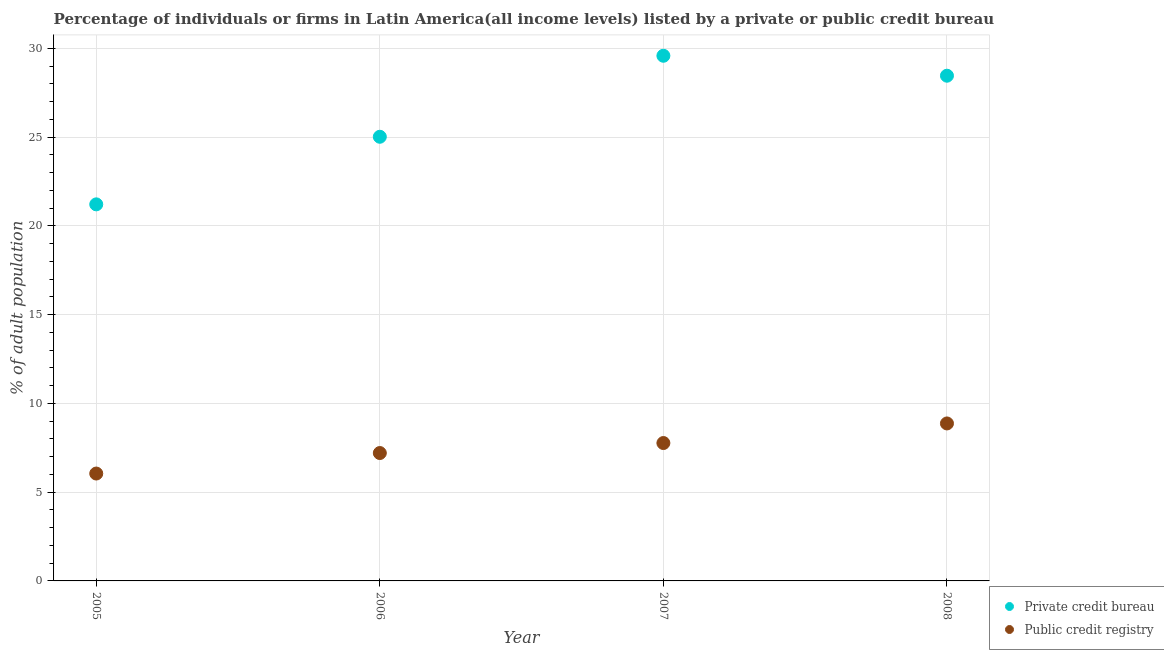Is the number of dotlines equal to the number of legend labels?
Keep it short and to the point. Yes. What is the percentage of firms listed by private credit bureau in 2005?
Provide a succinct answer. 21.21. Across all years, what is the maximum percentage of firms listed by private credit bureau?
Keep it short and to the point. 29.58. Across all years, what is the minimum percentage of firms listed by private credit bureau?
Your answer should be compact. 21.21. In which year was the percentage of firms listed by public credit bureau maximum?
Ensure brevity in your answer.  2008. In which year was the percentage of firms listed by public credit bureau minimum?
Provide a short and direct response. 2005. What is the total percentage of firms listed by private credit bureau in the graph?
Offer a terse response. 104.26. What is the difference between the percentage of firms listed by public credit bureau in 2006 and that in 2008?
Provide a succinct answer. -1.67. What is the difference between the percentage of firms listed by public credit bureau in 2008 and the percentage of firms listed by private credit bureau in 2005?
Provide a short and direct response. -12.34. What is the average percentage of firms listed by private credit bureau per year?
Offer a very short reply. 26.07. In the year 2005, what is the difference between the percentage of firms listed by private credit bureau and percentage of firms listed by public credit bureau?
Your answer should be compact. 15.16. In how many years, is the percentage of firms listed by public credit bureau greater than 8 %?
Provide a succinct answer. 1. What is the ratio of the percentage of firms listed by public credit bureau in 2007 to that in 2008?
Provide a short and direct response. 0.88. What is the difference between the highest and the second highest percentage of firms listed by public credit bureau?
Give a very brief answer. 1.1. What is the difference between the highest and the lowest percentage of firms listed by public credit bureau?
Offer a terse response. 2.82. Is the percentage of firms listed by public credit bureau strictly greater than the percentage of firms listed by private credit bureau over the years?
Offer a terse response. No. How many dotlines are there?
Provide a short and direct response. 2. How many years are there in the graph?
Make the answer very short. 4. What is the difference between two consecutive major ticks on the Y-axis?
Offer a terse response. 5. Does the graph contain grids?
Give a very brief answer. Yes. Where does the legend appear in the graph?
Ensure brevity in your answer.  Bottom right. How are the legend labels stacked?
Provide a succinct answer. Vertical. What is the title of the graph?
Your answer should be very brief. Percentage of individuals or firms in Latin America(all income levels) listed by a private or public credit bureau. Does "IMF nonconcessional" appear as one of the legend labels in the graph?
Provide a short and direct response. No. What is the label or title of the X-axis?
Provide a short and direct response. Year. What is the label or title of the Y-axis?
Offer a very short reply. % of adult population. What is the % of adult population in Private credit bureau in 2005?
Provide a succinct answer. 21.21. What is the % of adult population of Public credit registry in 2005?
Offer a very short reply. 6.05. What is the % of adult population of Private credit bureau in 2006?
Make the answer very short. 25.02. What is the % of adult population of Public credit registry in 2006?
Offer a terse response. 7.2. What is the % of adult population of Private credit bureau in 2007?
Keep it short and to the point. 29.58. What is the % of adult population in Public credit registry in 2007?
Your answer should be very brief. 7.77. What is the % of adult population in Private credit bureau in 2008?
Keep it short and to the point. 28.46. What is the % of adult population of Public credit registry in 2008?
Provide a short and direct response. 8.87. Across all years, what is the maximum % of adult population in Private credit bureau?
Your answer should be very brief. 29.58. Across all years, what is the maximum % of adult population in Public credit registry?
Your answer should be compact. 8.87. Across all years, what is the minimum % of adult population of Private credit bureau?
Your response must be concise. 21.21. Across all years, what is the minimum % of adult population of Public credit registry?
Your response must be concise. 6.05. What is the total % of adult population of Private credit bureau in the graph?
Make the answer very short. 104.26. What is the total % of adult population of Public credit registry in the graph?
Provide a short and direct response. 29.89. What is the difference between the % of adult population of Private credit bureau in 2005 and that in 2006?
Offer a very short reply. -3.81. What is the difference between the % of adult population of Public credit registry in 2005 and that in 2006?
Keep it short and to the point. -1.16. What is the difference between the % of adult population in Private credit bureau in 2005 and that in 2007?
Keep it short and to the point. -8.37. What is the difference between the % of adult population of Public credit registry in 2005 and that in 2007?
Provide a short and direct response. -1.72. What is the difference between the % of adult population in Private credit bureau in 2005 and that in 2008?
Your answer should be very brief. -7.25. What is the difference between the % of adult population of Public credit registry in 2005 and that in 2008?
Your response must be concise. -2.82. What is the difference between the % of adult population of Private credit bureau in 2006 and that in 2007?
Make the answer very short. -4.56. What is the difference between the % of adult population in Public credit registry in 2006 and that in 2007?
Keep it short and to the point. -0.56. What is the difference between the % of adult population in Private credit bureau in 2006 and that in 2008?
Offer a very short reply. -3.44. What is the difference between the % of adult population of Public credit registry in 2006 and that in 2008?
Your response must be concise. -1.67. What is the difference between the % of adult population in Private credit bureau in 2007 and that in 2008?
Provide a short and direct response. 1.12. What is the difference between the % of adult population of Public credit registry in 2007 and that in 2008?
Ensure brevity in your answer.  -1.1. What is the difference between the % of adult population of Private credit bureau in 2005 and the % of adult population of Public credit registry in 2006?
Your response must be concise. 14.01. What is the difference between the % of adult population in Private credit bureau in 2005 and the % of adult population in Public credit registry in 2007?
Give a very brief answer. 13.44. What is the difference between the % of adult population of Private credit bureau in 2005 and the % of adult population of Public credit registry in 2008?
Ensure brevity in your answer.  12.34. What is the difference between the % of adult population in Private credit bureau in 2006 and the % of adult population in Public credit registry in 2007?
Provide a short and direct response. 17.25. What is the difference between the % of adult population of Private credit bureau in 2006 and the % of adult population of Public credit registry in 2008?
Your answer should be very brief. 16.15. What is the difference between the % of adult population of Private credit bureau in 2007 and the % of adult population of Public credit registry in 2008?
Provide a short and direct response. 20.71. What is the average % of adult population in Private credit bureau per year?
Your answer should be compact. 26.07. What is the average % of adult population of Public credit registry per year?
Make the answer very short. 7.47. In the year 2005, what is the difference between the % of adult population of Private credit bureau and % of adult population of Public credit registry?
Give a very brief answer. 15.16. In the year 2006, what is the difference between the % of adult population of Private credit bureau and % of adult population of Public credit registry?
Provide a short and direct response. 17.81. In the year 2007, what is the difference between the % of adult population of Private credit bureau and % of adult population of Public credit registry?
Keep it short and to the point. 21.81. In the year 2008, what is the difference between the % of adult population of Private credit bureau and % of adult population of Public credit registry?
Offer a terse response. 19.59. What is the ratio of the % of adult population in Private credit bureau in 2005 to that in 2006?
Provide a short and direct response. 0.85. What is the ratio of the % of adult population of Public credit registry in 2005 to that in 2006?
Make the answer very short. 0.84. What is the ratio of the % of adult population of Private credit bureau in 2005 to that in 2007?
Keep it short and to the point. 0.72. What is the ratio of the % of adult population in Public credit registry in 2005 to that in 2007?
Provide a succinct answer. 0.78. What is the ratio of the % of adult population of Private credit bureau in 2005 to that in 2008?
Provide a short and direct response. 0.75. What is the ratio of the % of adult population in Public credit registry in 2005 to that in 2008?
Your response must be concise. 0.68. What is the ratio of the % of adult population of Private credit bureau in 2006 to that in 2007?
Keep it short and to the point. 0.85. What is the ratio of the % of adult population of Public credit registry in 2006 to that in 2007?
Your answer should be compact. 0.93. What is the ratio of the % of adult population in Private credit bureau in 2006 to that in 2008?
Keep it short and to the point. 0.88. What is the ratio of the % of adult population in Public credit registry in 2006 to that in 2008?
Ensure brevity in your answer.  0.81. What is the ratio of the % of adult population of Private credit bureau in 2007 to that in 2008?
Keep it short and to the point. 1.04. What is the ratio of the % of adult population of Public credit registry in 2007 to that in 2008?
Offer a terse response. 0.88. What is the difference between the highest and the second highest % of adult population of Private credit bureau?
Provide a succinct answer. 1.12. What is the difference between the highest and the second highest % of adult population of Public credit registry?
Give a very brief answer. 1.1. What is the difference between the highest and the lowest % of adult population in Private credit bureau?
Offer a very short reply. 8.37. What is the difference between the highest and the lowest % of adult population in Public credit registry?
Provide a short and direct response. 2.82. 